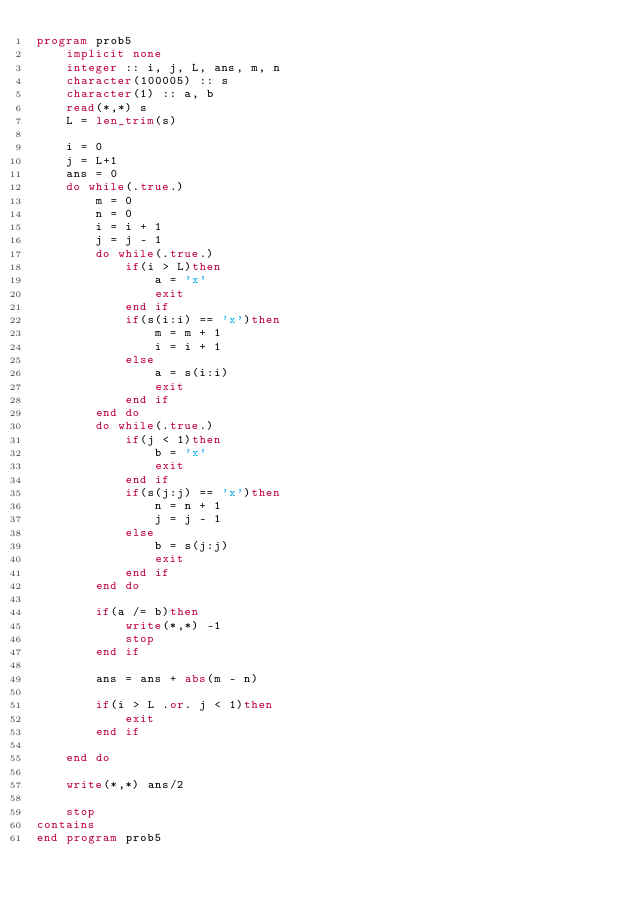<code> <loc_0><loc_0><loc_500><loc_500><_FORTRAN_>program prob5
    implicit none
    integer :: i, j, L, ans, m, n
    character(100005) :: s
    character(1) :: a, b
    read(*,*) s
    L = len_trim(s)

    i = 0
    j = L+1
    ans = 0
    do while(.true.)
        m = 0
        n = 0
        i = i + 1
        j = j - 1
        do while(.true.)
            if(i > L)then
                a = 'x'
                exit
            end if
            if(s(i:i) == 'x')then
                m = m + 1
                i = i + 1
            else
                a = s(i:i)
                exit
            end if
        end do
        do while(.true.)
            if(j < 1)then
                b = 'x'
                exit
            end if
            if(s(j:j) == 'x')then
                n = n + 1
                j = j - 1
            else
                b = s(j:j)
                exit
            end if
        end do        

        if(a /= b)then
            write(*,*) -1
            stop
        end if
        
        ans = ans + abs(m - n)

        if(i > L .or. j < 1)then
            exit
        end if
        
    end do

    write(*,*) ans/2

    stop
contains
end program prob5</code> 